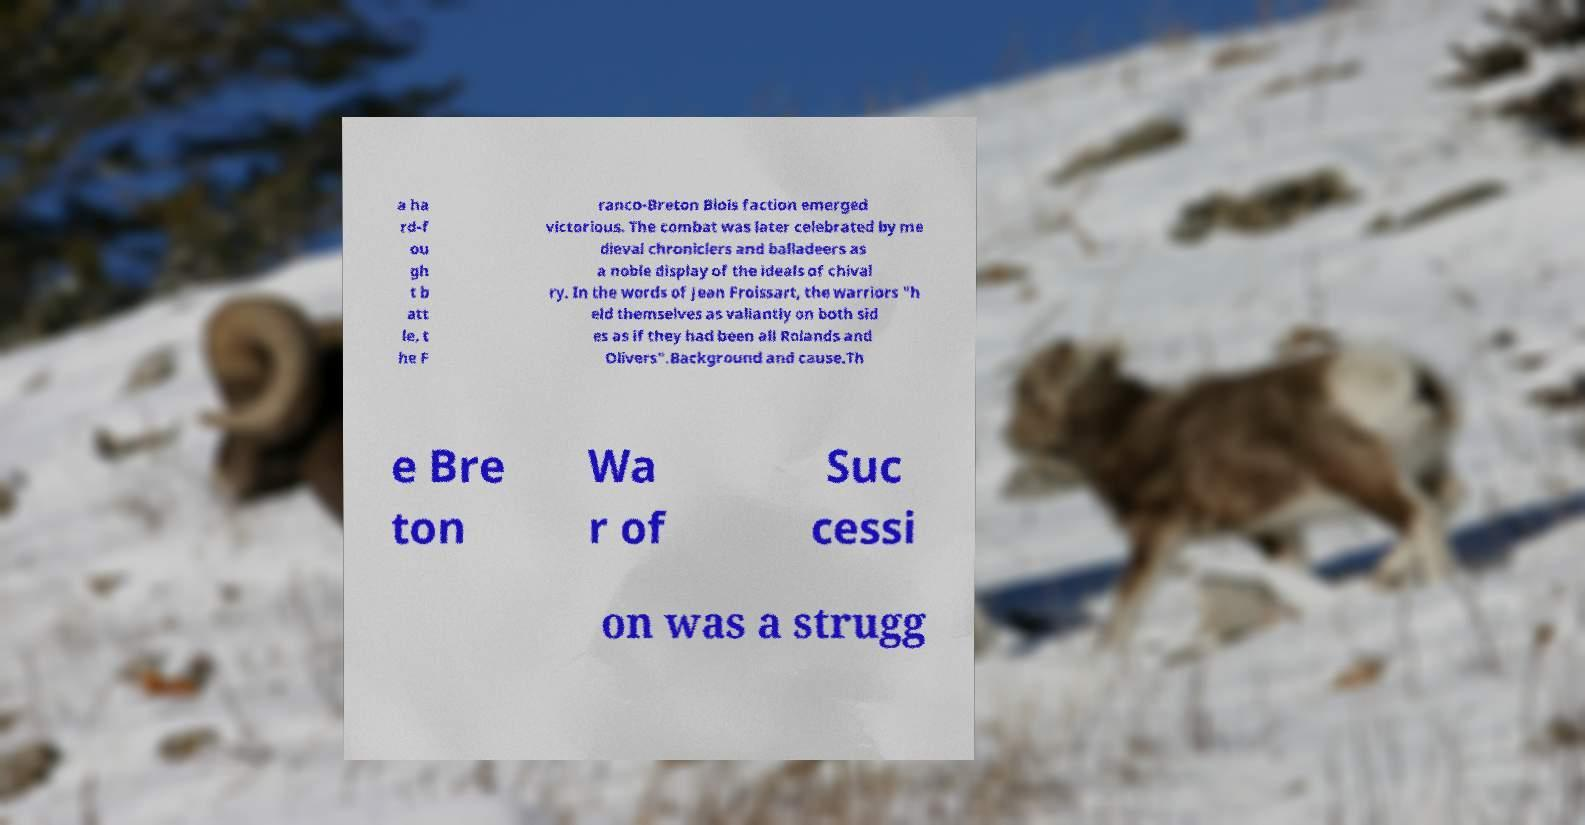I need the written content from this picture converted into text. Can you do that? a ha rd-f ou gh t b att le, t he F ranco-Breton Blois faction emerged victorious. The combat was later celebrated by me dieval chroniclers and balladeers as a noble display of the ideals of chival ry. In the words of Jean Froissart, the warriors "h eld themselves as valiantly on both sid es as if they had been all Rolands and Olivers".Background and cause.Th e Bre ton Wa r of Suc cessi on was a strugg 